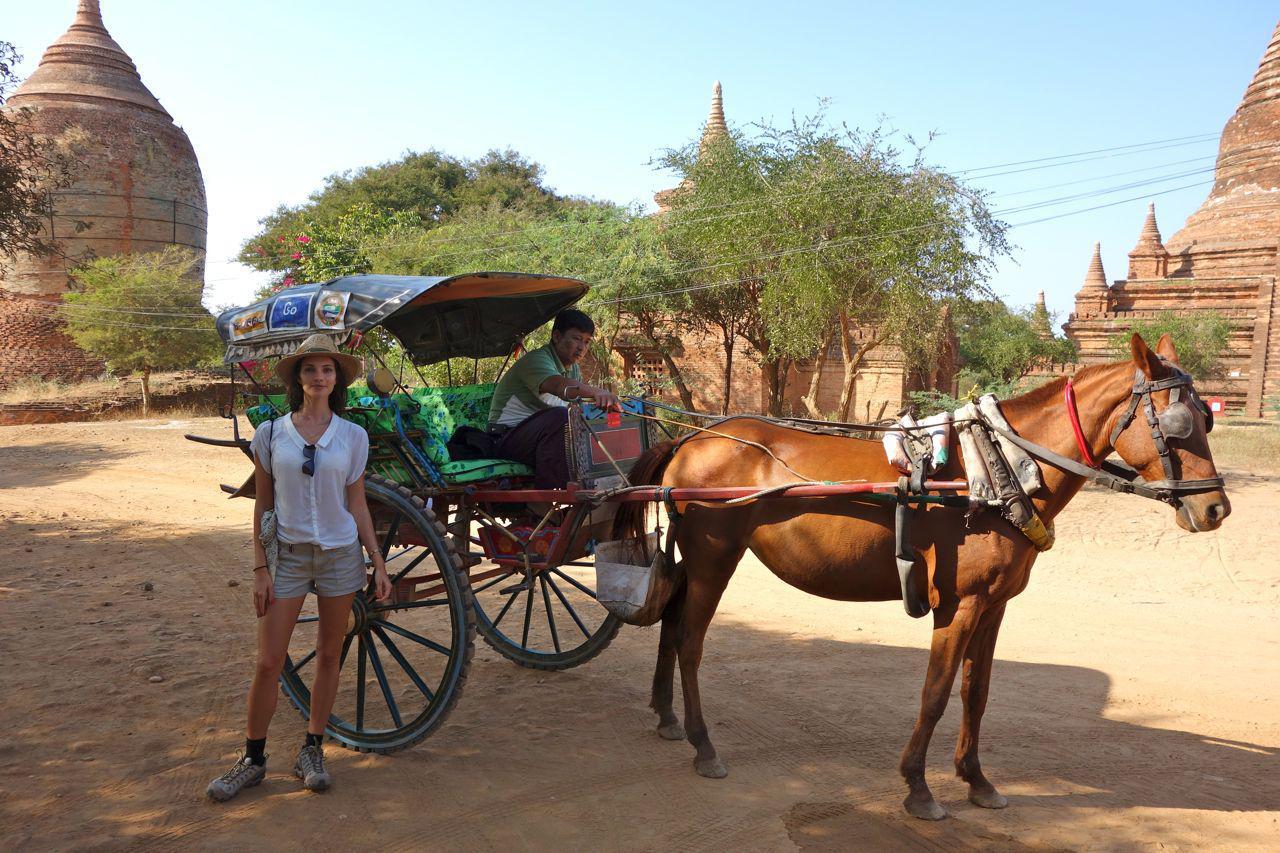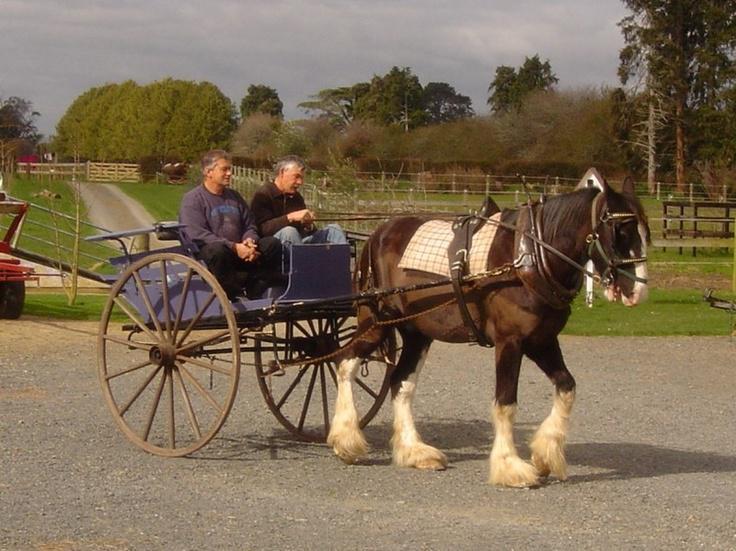The first image is the image on the left, the second image is the image on the right. Considering the images on both sides, is "The horses in the image on the right have furry feet." valid? Answer yes or no. Yes. The first image is the image on the left, the second image is the image on the right. Assess this claim about the two images: "An image shows a cart pulled by two Clydesdale horses only.". Correct or not? Answer yes or no. No. 